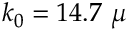Convert formula to latex. <formula><loc_0><loc_0><loc_500><loc_500>k _ { 0 } = 1 4 . 7 \mu</formula> 